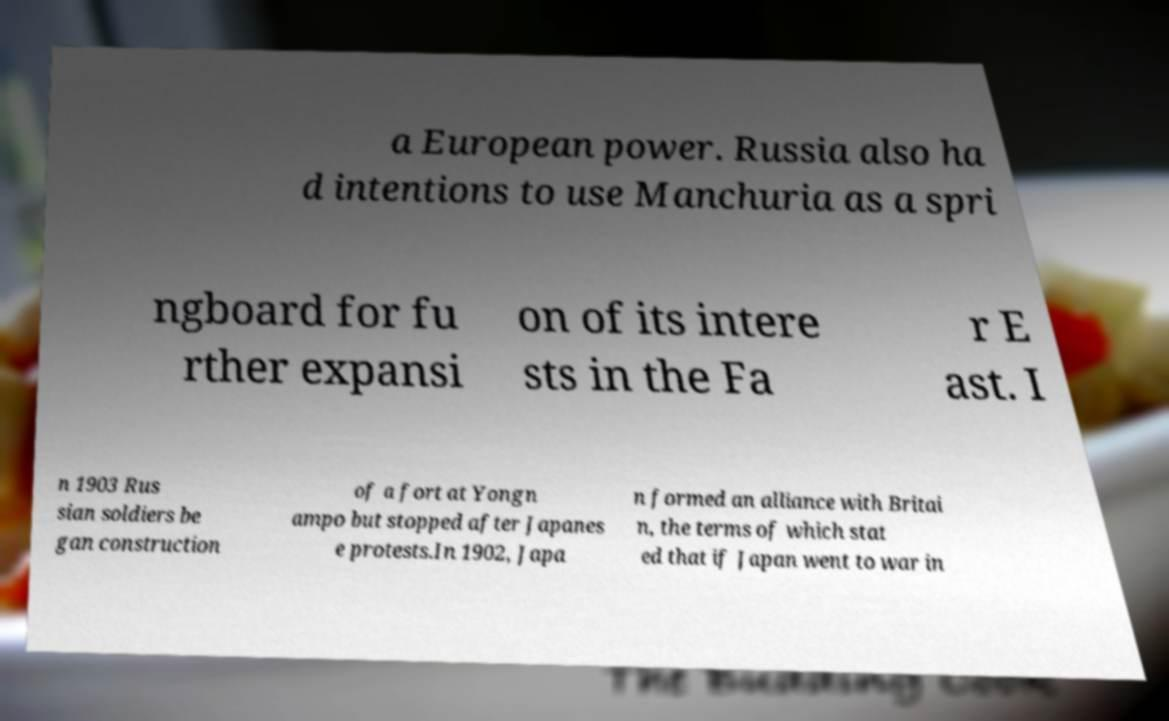Can you accurately transcribe the text from the provided image for me? a European power. Russia also ha d intentions to use Manchuria as a spri ngboard for fu rther expansi on of its intere sts in the Fa r E ast. I n 1903 Rus sian soldiers be gan construction of a fort at Yongn ampo but stopped after Japanes e protests.In 1902, Japa n formed an alliance with Britai n, the terms of which stat ed that if Japan went to war in 